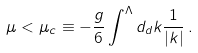Convert formula to latex. <formula><loc_0><loc_0><loc_500><loc_500>\mu < \mu _ { c } \equiv - \frac { g } { 6 } \int ^ { \Lambda } d _ { d } k \frac { 1 } { | k | } \, .</formula> 